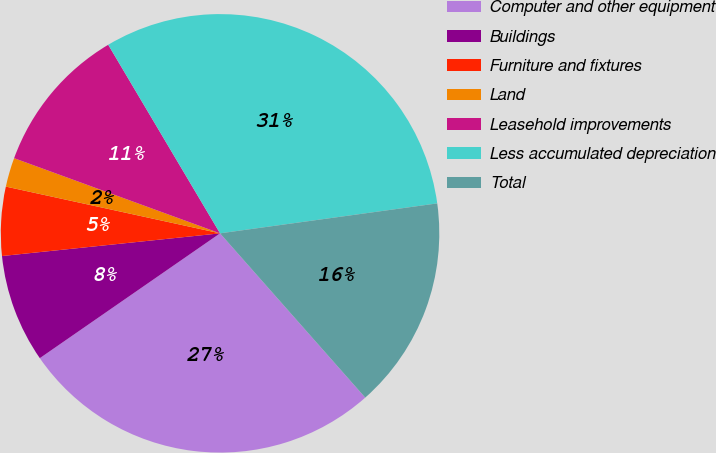Convert chart. <chart><loc_0><loc_0><loc_500><loc_500><pie_chart><fcel>Computer and other equipment<fcel>Buildings<fcel>Furniture and fixtures<fcel>Land<fcel>Leasehold improvements<fcel>Less accumulated depreciation<fcel>Total<nl><fcel>26.88%<fcel>7.99%<fcel>5.07%<fcel>2.15%<fcel>10.91%<fcel>31.34%<fcel>15.66%<nl></chart> 